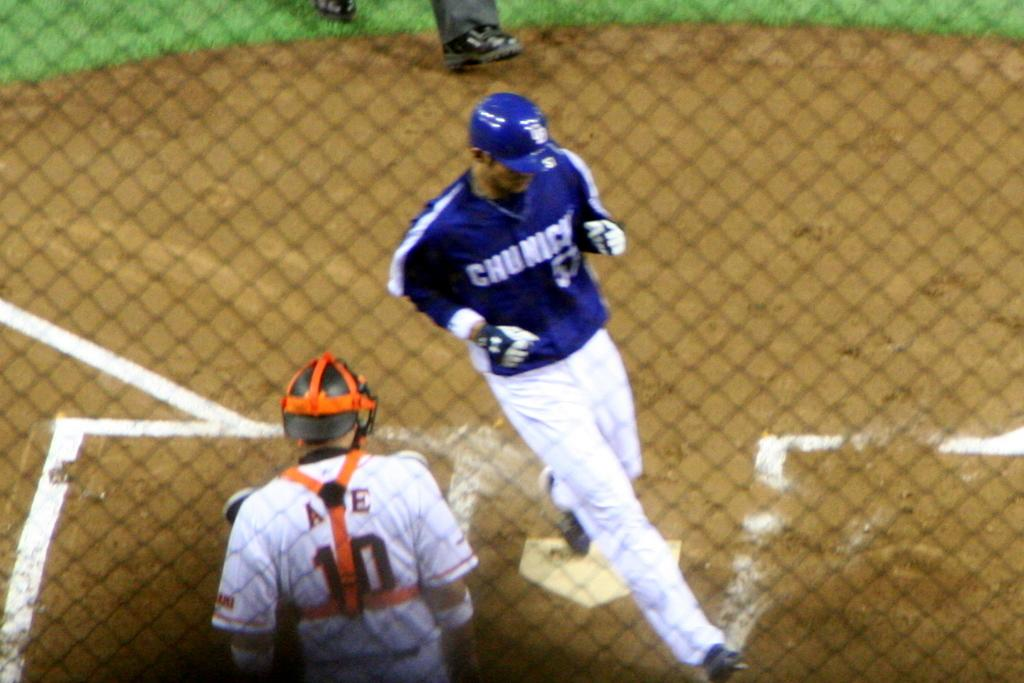Provide a one-sentence caption for the provided image. Catcher number 10 watches as a player crosses home plate. 